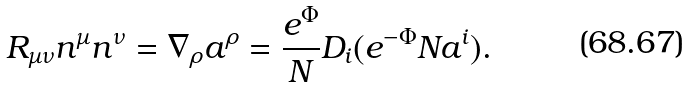<formula> <loc_0><loc_0><loc_500><loc_500>R _ { \mu \nu } n ^ { \mu } n ^ { \nu } = \nabla _ { \rho } a ^ { \rho } = \frac { e ^ { \Phi } } { N } D _ { i } ( e ^ { - \Phi } N a ^ { i } ) .</formula> 